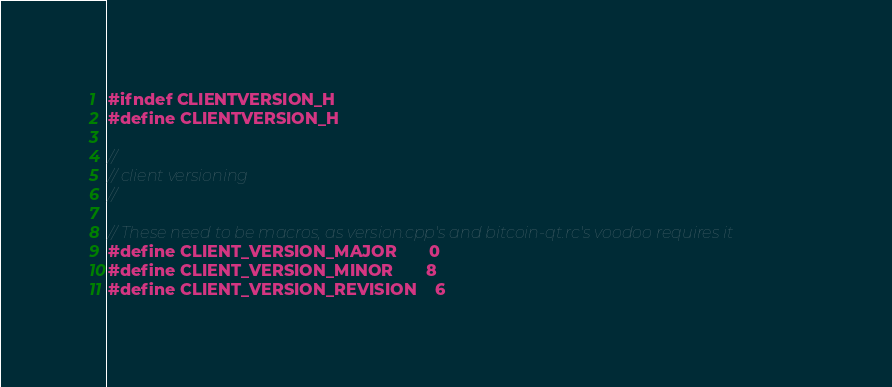<code> <loc_0><loc_0><loc_500><loc_500><_C_>#ifndef CLIENTVERSION_H
#define CLIENTVERSION_H

//
// client versioning
//

// These need to be macros, as version.cpp's and bitcoin-qt.rc's voodoo requires it
#define CLIENT_VERSION_MAJOR       0
#define CLIENT_VERSION_MINOR       8
#define CLIENT_VERSION_REVISION    6</code> 